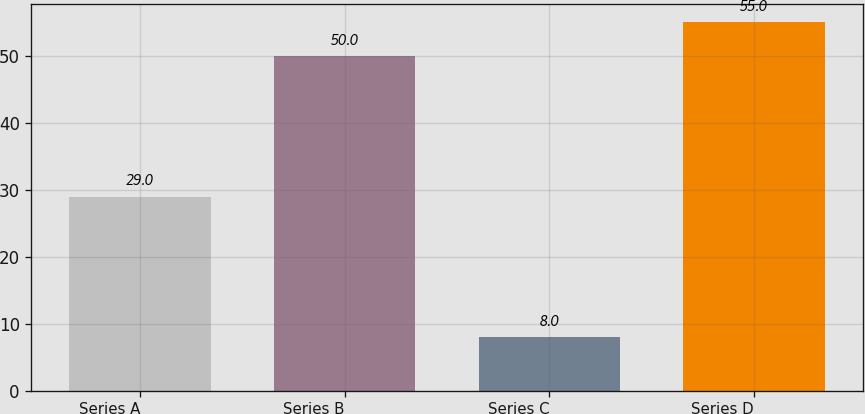Convert chart. <chart><loc_0><loc_0><loc_500><loc_500><bar_chart><fcel>Series A<fcel>Series B<fcel>Series C<fcel>Series D<nl><fcel>29<fcel>50<fcel>8<fcel>55<nl></chart> 